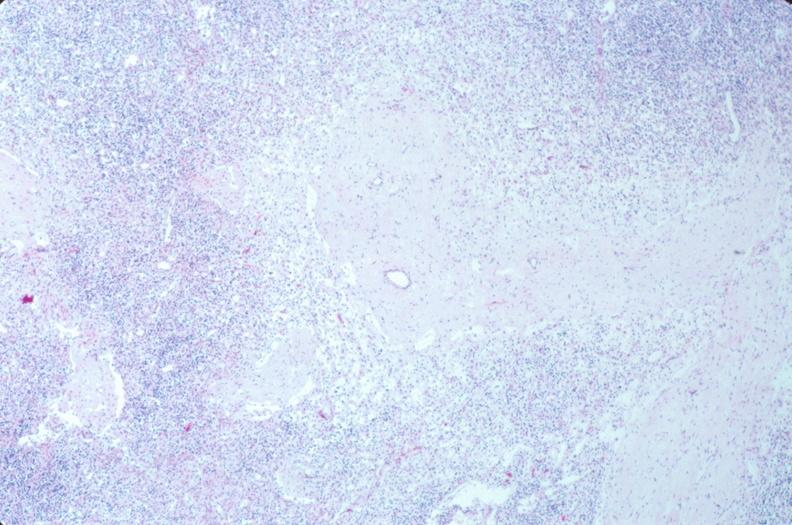what does this image show?
Answer the question using a single word or phrase. Lymph nodes 